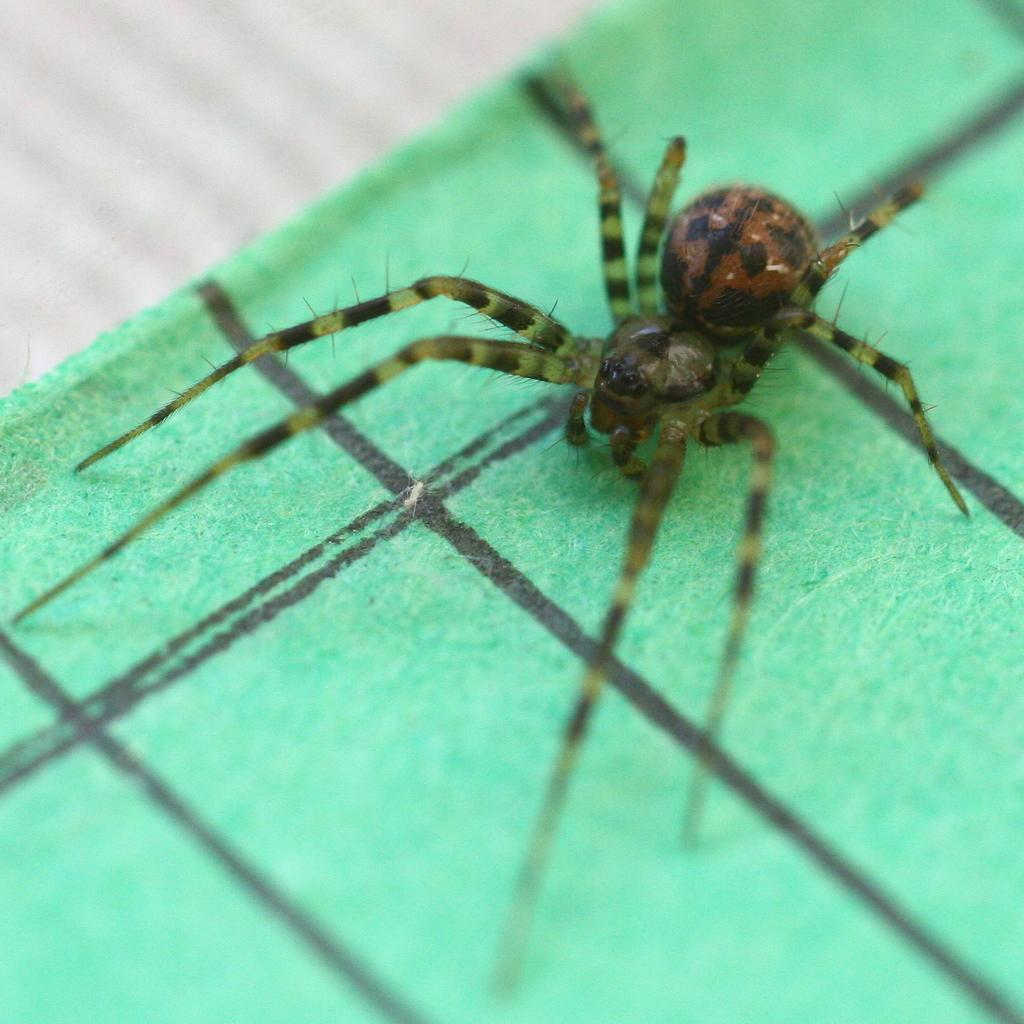What is the main subject of the image? The main subject of the image is a spider. Can you describe the appearance of the spider? The spider is brown, black, and green in color. What is the spider resting on in the image? The spider is on a green and black colored object. What color is the background of the image? The background of the image is white. How does the machine crush the spider in the image? There is no machine present in the image, and the spider is not being crushed. 